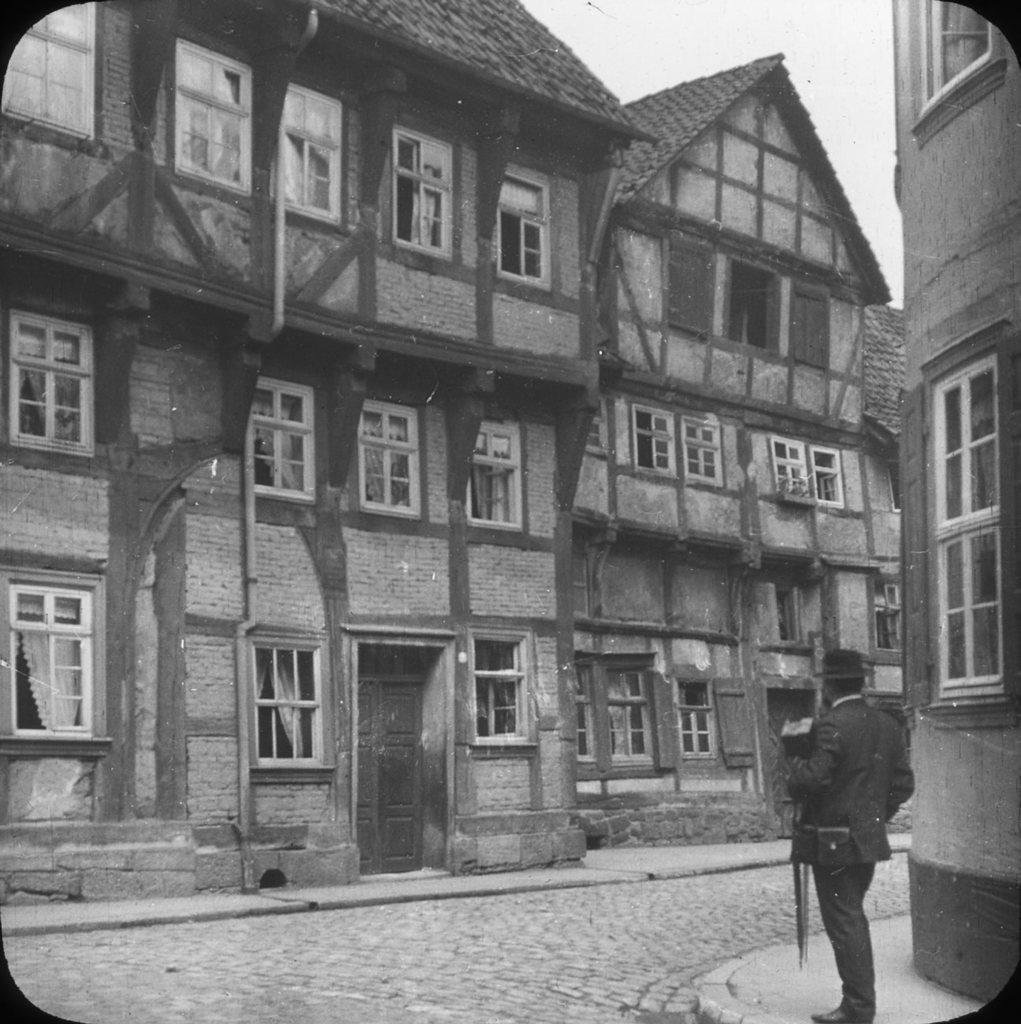Could you give a brief overview of what you see in this image? In this image I can see a person standing, in front I can see a building and sky, and the image is in black and white. 